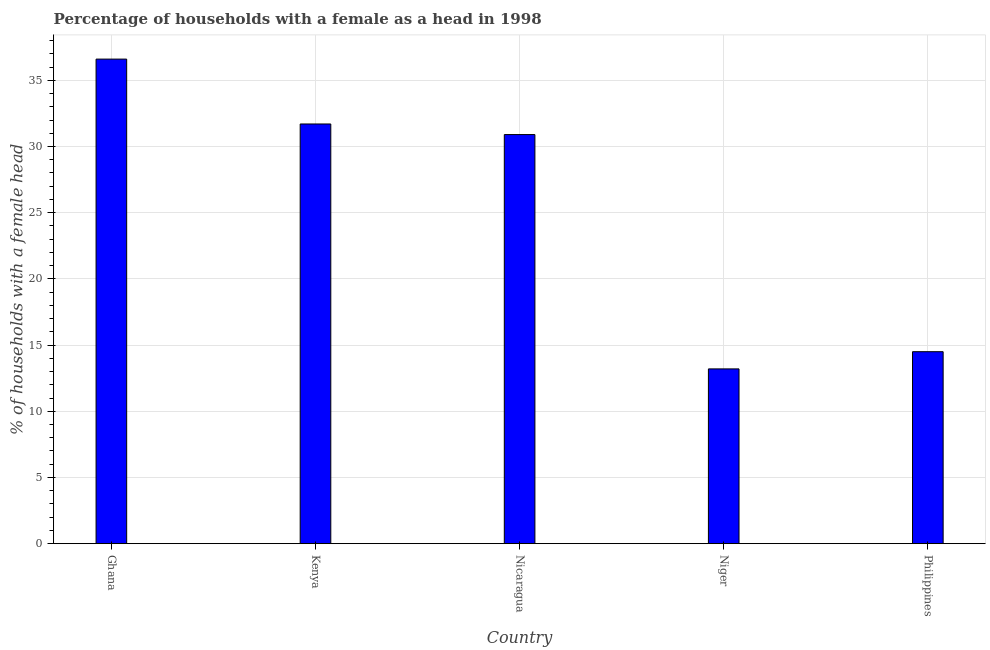Does the graph contain any zero values?
Your answer should be compact. No. What is the title of the graph?
Give a very brief answer. Percentage of households with a female as a head in 1998. What is the label or title of the X-axis?
Make the answer very short. Country. What is the label or title of the Y-axis?
Offer a terse response. % of households with a female head. What is the number of female supervised households in Nicaragua?
Your answer should be compact. 30.9. Across all countries, what is the maximum number of female supervised households?
Provide a short and direct response. 36.6. Across all countries, what is the minimum number of female supervised households?
Offer a very short reply. 13.2. In which country was the number of female supervised households maximum?
Offer a terse response. Ghana. In which country was the number of female supervised households minimum?
Make the answer very short. Niger. What is the sum of the number of female supervised households?
Provide a succinct answer. 126.9. What is the difference between the number of female supervised households in Kenya and Nicaragua?
Your answer should be very brief. 0.8. What is the average number of female supervised households per country?
Give a very brief answer. 25.38. What is the median number of female supervised households?
Your answer should be very brief. 30.9. In how many countries, is the number of female supervised households greater than 18 %?
Make the answer very short. 3. What is the ratio of the number of female supervised households in Ghana to that in Kenya?
Offer a very short reply. 1.16. Is the number of female supervised households in Kenya less than that in Nicaragua?
Your answer should be very brief. No. What is the difference between the highest and the second highest number of female supervised households?
Offer a terse response. 4.9. What is the difference between the highest and the lowest number of female supervised households?
Offer a very short reply. 23.4. In how many countries, is the number of female supervised households greater than the average number of female supervised households taken over all countries?
Provide a succinct answer. 3. How many bars are there?
Keep it short and to the point. 5. How many countries are there in the graph?
Provide a succinct answer. 5. What is the difference between two consecutive major ticks on the Y-axis?
Offer a very short reply. 5. What is the % of households with a female head in Ghana?
Offer a very short reply. 36.6. What is the % of households with a female head in Kenya?
Offer a terse response. 31.7. What is the % of households with a female head in Nicaragua?
Make the answer very short. 30.9. What is the difference between the % of households with a female head in Ghana and Nicaragua?
Your answer should be compact. 5.7. What is the difference between the % of households with a female head in Ghana and Niger?
Give a very brief answer. 23.4. What is the difference between the % of households with a female head in Ghana and Philippines?
Give a very brief answer. 22.1. What is the difference between the % of households with a female head in Kenya and Nicaragua?
Provide a succinct answer. 0.8. What is the difference between the % of households with a female head in Kenya and Niger?
Ensure brevity in your answer.  18.5. What is the difference between the % of households with a female head in Kenya and Philippines?
Ensure brevity in your answer.  17.2. What is the difference between the % of households with a female head in Nicaragua and Philippines?
Offer a terse response. 16.4. What is the difference between the % of households with a female head in Niger and Philippines?
Your answer should be compact. -1.3. What is the ratio of the % of households with a female head in Ghana to that in Kenya?
Your answer should be compact. 1.16. What is the ratio of the % of households with a female head in Ghana to that in Nicaragua?
Give a very brief answer. 1.18. What is the ratio of the % of households with a female head in Ghana to that in Niger?
Offer a terse response. 2.77. What is the ratio of the % of households with a female head in Ghana to that in Philippines?
Your answer should be compact. 2.52. What is the ratio of the % of households with a female head in Kenya to that in Niger?
Keep it short and to the point. 2.4. What is the ratio of the % of households with a female head in Kenya to that in Philippines?
Give a very brief answer. 2.19. What is the ratio of the % of households with a female head in Nicaragua to that in Niger?
Offer a terse response. 2.34. What is the ratio of the % of households with a female head in Nicaragua to that in Philippines?
Your answer should be compact. 2.13. What is the ratio of the % of households with a female head in Niger to that in Philippines?
Your answer should be compact. 0.91. 